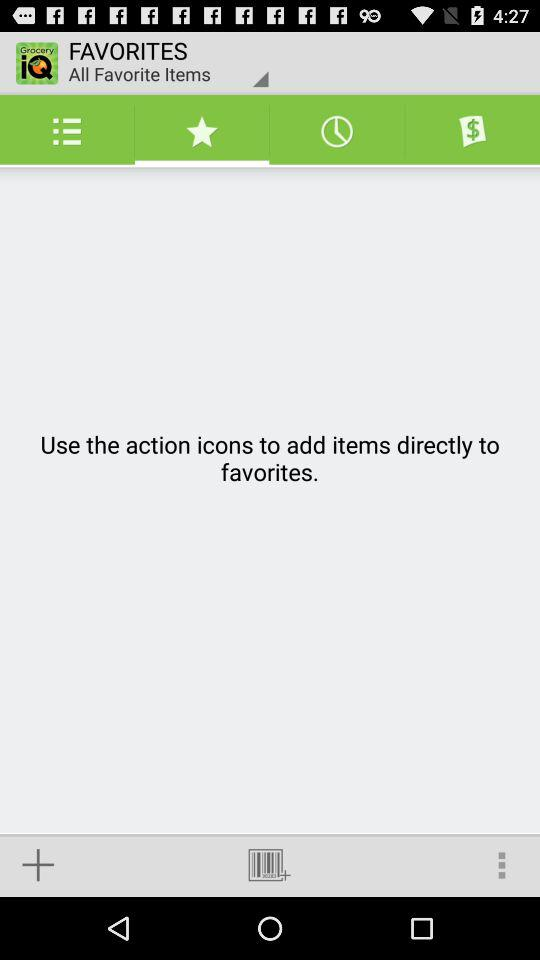What is the name of the application? The name of the application is "Grocery iQ". 